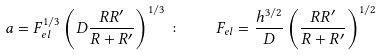Convert formula to latex. <formula><loc_0><loc_0><loc_500><loc_500>a = F _ { e l } ^ { 1 / 3 } \left ( D \frac { R R ^ { \prime } } { R + R ^ { \prime } } \right ) ^ { 1 / 3 } \colon \quad F _ { e l } = \frac { h ^ { 3 / 2 } } { D } \left ( \frac { R R ^ { \prime } } { R + R ^ { \prime } } \right ) ^ { 1 / 2 }</formula> 